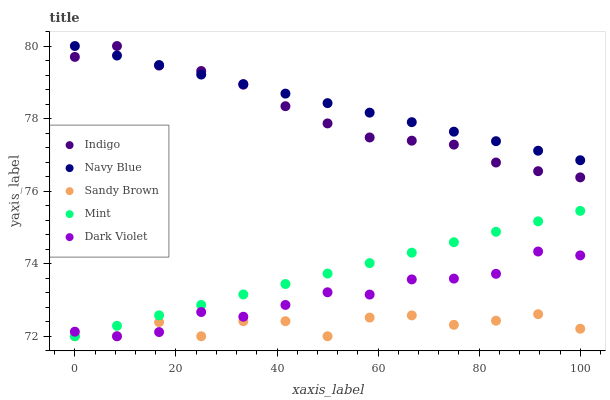Does Sandy Brown have the minimum area under the curve?
Answer yes or no. Yes. Does Navy Blue have the maximum area under the curve?
Answer yes or no. Yes. Does Dark Violet have the minimum area under the curve?
Answer yes or no. No. Does Dark Violet have the maximum area under the curve?
Answer yes or no. No. Is Mint the smoothest?
Answer yes or no. Yes. Is Sandy Brown the roughest?
Answer yes or no. Yes. Is Dark Violet the smoothest?
Answer yes or no. No. Is Dark Violet the roughest?
Answer yes or no. No. Does Dark Violet have the lowest value?
Answer yes or no. Yes. Does Indigo have the lowest value?
Answer yes or no. No. Does Indigo have the highest value?
Answer yes or no. Yes. Does Dark Violet have the highest value?
Answer yes or no. No. Is Mint less than Indigo?
Answer yes or no. Yes. Is Indigo greater than Mint?
Answer yes or no. Yes. Does Navy Blue intersect Indigo?
Answer yes or no. Yes. Is Navy Blue less than Indigo?
Answer yes or no. No. Is Navy Blue greater than Indigo?
Answer yes or no. No. Does Mint intersect Indigo?
Answer yes or no. No. 